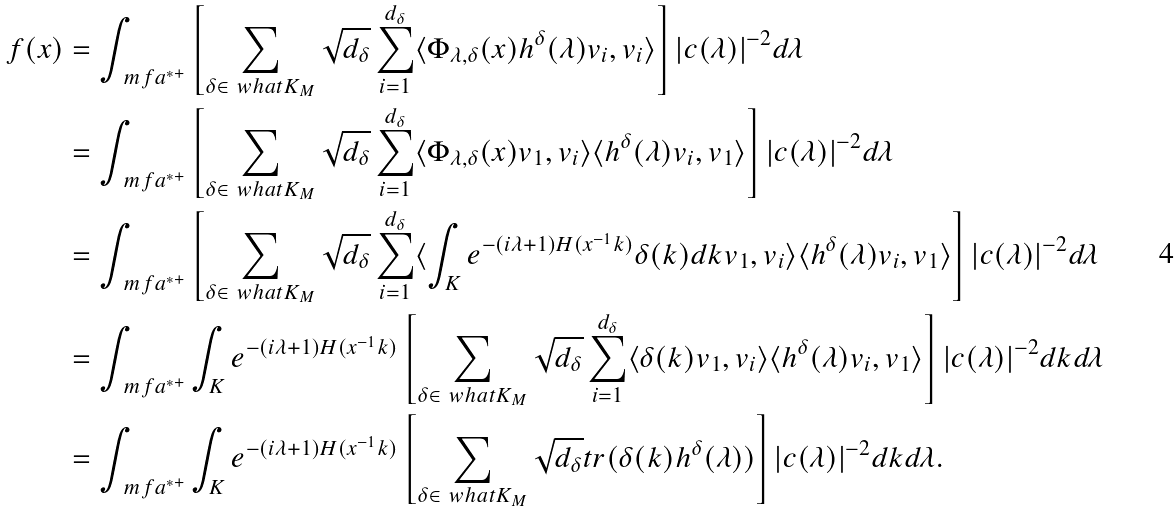<formula> <loc_0><loc_0><loc_500><loc_500>f ( x ) & = \int _ { \ m f a ^ { * + } } \left [ \sum _ { \delta \in \ w h a t { K } _ { M } } \sqrt { d _ { \delta } } \sum _ { i = 1 } ^ { d _ { \delta } } \langle \Phi _ { \lambda , \delta } ( x ) h ^ { \delta } ( \lambda ) v _ { i } , v _ { i } \rangle \right ] | c ( \lambda ) | ^ { - 2 } d \lambda \\ & = \int _ { \ m f a ^ { * + } } \left [ \sum _ { \delta \in \ w h a t { K } _ { M } } \sqrt { d _ { \delta } } \sum _ { i = 1 } ^ { d _ { \delta } } \langle \Phi _ { \lambda , \delta } ( x ) v _ { 1 } , v _ { i } \rangle \langle h ^ { \delta } ( \lambda ) v _ { i } , v _ { 1 } \rangle \right ] | c ( \lambda ) | ^ { - 2 } d \lambda \\ & = \int _ { \ m f a ^ { * + } } \left [ \sum _ { \delta \in \ w h a t { K } _ { M } } \sqrt { d _ { \delta } } \sum _ { i = 1 } ^ { d _ { \delta } } \langle \int _ { K } e ^ { - ( i \lambda + 1 ) H ( x ^ { - 1 } k ) } \delta ( k ) d k v _ { 1 } , v _ { i } \rangle \langle h ^ { \delta } ( \lambda ) v _ { i } , v _ { 1 } \rangle \right ] | c ( \lambda ) | ^ { - 2 } d \lambda \\ & = \int _ { \ m f a ^ { * + } } \int _ { K } e ^ { - ( i \lambda + 1 ) H ( x ^ { - 1 } k ) } \left [ \sum _ { \delta \in \ w h a t { K } _ { M } } \sqrt { d _ { \delta } } \sum _ { i = 1 } ^ { d _ { \delta } } \langle \delta ( k ) v _ { 1 } , v _ { i } \rangle \langle h ^ { \delta } ( \lambda ) v _ { i } , v _ { 1 } \rangle \right ] | c ( \lambda ) | ^ { - 2 } d k d \lambda \\ & = \int _ { \ m f a ^ { * + } } \int _ { K } e ^ { - ( i \lambda + 1 ) H ( x ^ { - 1 } k ) } \left [ \sum _ { \delta \in \ w h a t { K } _ { M } } \sqrt { d _ { \delta } } t r ( \delta ( k ) h ^ { \delta } ( \lambda ) ) \right ] | c ( \lambda ) | ^ { - 2 } d k d \lambda .</formula> 